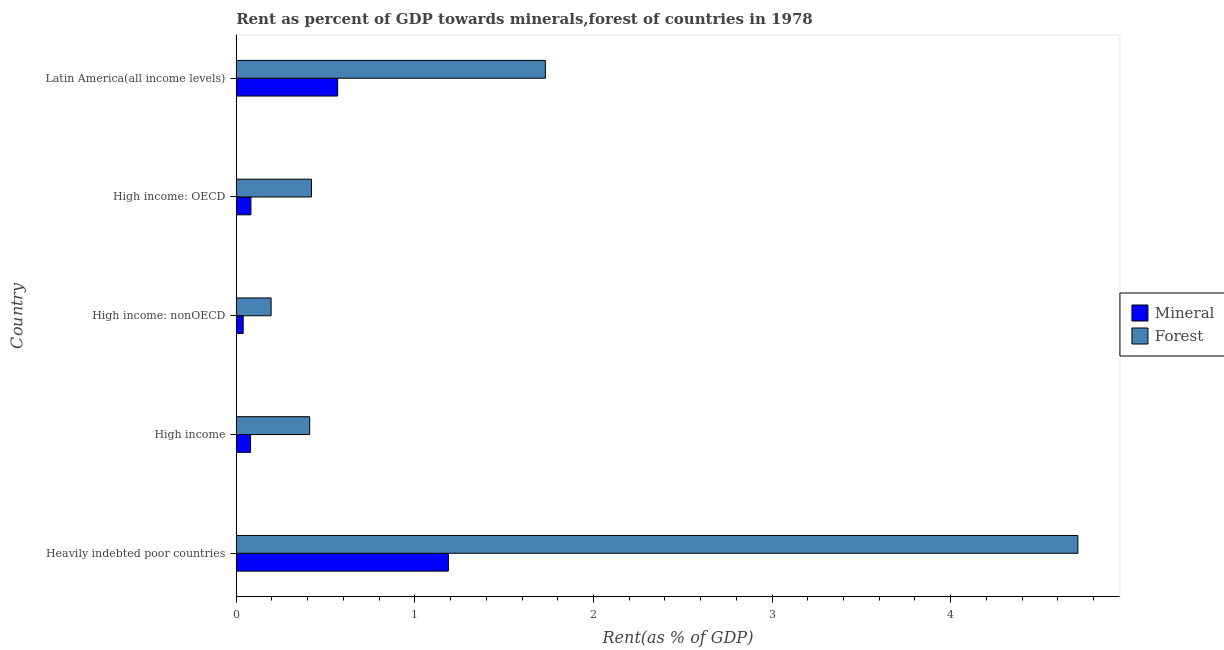How many different coloured bars are there?
Offer a terse response. 2. Are the number of bars per tick equal to the number of legend labels?
Offer a terse response. Yes. Are the number of bars on each tick of the Y-axis equal?
Your answer should be compact. Yes. What is the label of the 1st group of bars from the top?
Make the answer very short. Latin America(all income levels). What is the forest rent in High income: nonOECD?
Keep it short and to the point. 0.2. Across all countries, what is the maximum forest rent?
Provide a short and direct response. 4.71. Across all countries, what is the minimum mineral rent?
Your response must be concise. 0.04. In which country was the mineral rent maximum?
Your response must be concise. Heavily indebted poor countries. In which country was the forest rent minimum?
Keep it short and to the point. High income: nonOECD. What is the total forest rent in the graph?
Keep it short and to the point. 7.47. What is the difference between the forest rent in High income: nonOECD and that in Latin America(all income levels)?
Provide a succinct answer. -1.54. What is the difference between the forest rent in High income and the mineral rent in Heavily indebted poor countries?
Give a very brief answer. -0.78. What is the average forest rent per country?
Make the answer very short. 1.49. What is the difference between the forest rent and mineral rent in High income: OECD?
Make the answer very short. 0.34. What is the ratio of the mineral rent in Heavily indebted poor countries to that in High income: OECD?
Keep it short and to the point. 14.48. Is the mineral rent in High income less than that in High income: nonOECD?
Your answer should be very brief. No. Is the difference between the mineral rent in High income: OECD and Latin America(all income levels) greater than the difference between the forest rent in High income: OECD and Latin America(all income levels)?
Offer a terse response. Yes. What is the difference between the highest and the second highest mineral rent?
Provide a succinct answer. 0.62. What is the difference between the highest and the lowest forest rent?
Offer a very short reply. 4.52. What does the 1st bar from the top in High income represents?
Give a very brief answer. Forest. What does the 2nd bar from the bottom in Heavily indebted poor countries represents?
Your response must be concise. Forest. How many bars are there?
Give a very brief answer. 10. What is the difference between two consecutive major ticks on the X-axis?
Make the answer very short. 1. Does the graph contain any zero values?
Make the answer very short. No. Does the graph contain grids?
Offer a very short reply. No. How are the legend labels stacked?
Offer a terse response. Vertical. What is the title of the graph?
Make the answer very short. Rent as percent of GDP towards minerals,forest of countries in 1978. What is the label or title of the X-axis?
Provide a short and direct response. Rent(as % of GDP). What is the Rent(as % of GDP) of Mineral in Heavily indebted poor countries?
Make the answer very short. 1.19. What is the Rent(as % of GDP) in Forest in Heavily indebted poor countries?
Your answer should be compact. 4.71. What is the Rent(as % of GDP) in Mineral in High income?
Provide a succinct answer. 0.08. What is the Rent(as % of GDP) in Forest in High income?
Provide a short and direct response. 0.41. What is the Rent(as % of GDP) of Mineral in High income: nonOECD?
Make the answer very short. 0.04. What is the Rent(as % of GDP) of Forest in High income: nonOECD?
Provide a succinct answer. 0.2. What is the Rent(as % of GDP) in Mineral in High income: OECD?
Your answer should be compact. 0.08. What is the Rent(as % of GDP) of Forest in High income: OECD?
Make the answer very short. 0.42. What is the Rent(as % of GDP) of Mineral in Latin America(all income levels)?
Your answer should be very brief. 0.57. What is the Rent(as % of GDP) of Forest in Latin America(all income levels)?
Provide a succinct answer. 1.73. Across all countries, what is the maximum Rent(as % of GDP) in Mineral?
Give a very brief answer. 1.19. Across all countries, what is the maximum Rent(as % of GDP) in Forest?
Offer a terse response. 4.71. Across all countries, what is the minimum Rent(as % of GDP) of Mineral?
Give a very brief answer. 0.04. Across all countries, what is the minimum Rent(as % of GDP) in Forest?
Keep it short and to the point. 0.2. What is the total Rent(as % of GDP) in Mineral in the graph?
Offer a very short reply. 1.96. What is the total Rent(as % of GDP) in Forest in the graph?
Offer a terse response. 7.47. What is the difference between the Rent(as % of GDP) of Mineral in Heavily indebted poor countries and that in High income?
Your answer should be very brief. 1.11. What is the difference between the Rent(as % of GDP) in Forest in Heavily indebted poor countries and that in High income?
Your answer should be compact. 4.3. What is the difference between the Rent(as % of GDP) in Mineral in Heavily indebted poor countries and that in High income: nonOECD?
Provide a short and direct response. 1.15. What is the difference between the Rent(as % of GDP) of Forest in Heavily indebted poor countries and that in High income: nonOECD?
Offer a terse response. 4.52. What is the difference between the Rent(as % of GDP) in Mineral in Heavily indebted poor countries and that in High income: OECD?
Make the answer very short. 1.11. What is the difference between the Rent(as % of GDP) in Forest in Heavily indebted poor countries and that in High income: OECD?
Provide a succinct answer. 4.29. What is the difference between the Rent(as % of GDP) in Mineral in Heavily indebted poor countries and that in Latin America(all income levels)?
Offer a very short reply. 0.62. What is the difference between the Rent(as % of GDP) in Forest in Heavily indebted poor countries and that in Latin America(all income levels)?
Ensure brevity in your answer.  2.98. What is the difference between the Rent(as % of GDP) of Mineral in High income and that in High income: nonOECD?
Keep it short and to the point. 0.04. What is the difference between the Rent(as % of GDP) of Forest in High income and that in High income: nonOECD?
Ensure brevity in your answer.  0.22. What is the difference between the Rent(as % of GDP) in Mineral in High income and that in High income: OECD?
Offer a terse response. -0. What is the difference between the Rent(as % of GDP) in Forest in High income and that in High income: OECD?
Offer a very short reply. -0.01. What is the difference between the Rent(as % of GDP) in Mineral in High income and that in Latin America(all income levels)?
Make the answer very short. -0.49. What is the difference between the Rent(as % of GDP) in Forest in High income and that in Latin America(all income levels)?
Provide a short and direct response. -1.32. What is the difference between the Rent(as % of GDP) in Mineral in High income: nonOECD and that in High income: OECD?
Keep it short and to the point. -0.04. What is the difference between the Rent(as % of GDP) in Forest in High income: nonOECD and that in High income: OECD?
Your answer should be compact. -0.23. What is the difference between the Rent(as % of GDP) in Mineral in High income: nonOECD and that in Latin America(all income levels)?
Your response must be concise. -0.53. What is the difference between the Rent(as % of GDP) in Forest in High income: nonOECD and that in Latin America(all income levels)?
Provide a short and direct response. -1.54. What is the difference between the Rent(as % of GDP) in Mineral in High income: OECD and that in Latin America(all income levels)?
Your answer should be very brief. -0.49. What is the difference between the Rent(as % of GDP) in Forest in High income: OECD and that in Latin America(all income levels)?
Your answer should be compact. -1.31. What is the difference between the Rent(as % of GDP) of Mineral in Heavily indebted poor countries and the Rent(as % of GDP) of Forest in High income?
Give a very brief answer. 0.78. What is the difference between the Rent(as % of GDP) of Mineral in Heavily indebted poor countries and the Rent(as % of GDP) of Forest in High income: OECD?
Give a very brief answer. 0.77. What is the difference between the Rent(as % of GDP) of Mineral in Heavily indebted poor countries and the Rent(as % of GDP) of Forest in Latin America(all income levels)?
Ensure brevity in your answer.  -0.54. What is the difference between the Rent(as % of GDP) in Mineral in High income and the Rent(as % of GDP) in Forest in High income: nonOECD?
Ensure brevity in your answer.  -0.12. What is the difference between the Rent(as % of GDP) of Mineral in High income and the Rent(as % of GDP) of Forest in High income: OECD?
Make the answer very short. -0.34. What is the difference between the Rent(as % of GDP) of Mineral in High income and the Rent(as % of GDP) of Forest in Latin America(all income levels)?
Offer a terse response. -1.65. What is the difference between the Rent(as % of GDP) of Mineral in High income: nonOECD and the Rent(as % of GDP) of Forest in High income: OECD?
Ensure brevity in your answer.  -0.38. What is the difference between the Rent(as % of GDP) of Mineral in High income: nonOECD and the Rent(as % of GDP) of Forest in Latin America(all income levels)?
Your answer should be very brief. -1.69. What is the difference between the Rent(as % of GDP) of Mineral in High income: OECD and the Rent(as % of GDP) of Forest in Latin America(all income levels)?
Provide a succinct answer. -1.65. What is the average Rent(as % of GDP) in Mineral per country?
Provide a short and direct response. 0.39. What is the average Rent(as % of GDP) in Forest per country?
Provide a succinct answer. 1.49. What is the difference between the Rent(as % of GDP) of Mineral and Rent(as % of GDP) of Forest in Heavily indebted poor countries?
Your response must be concise. -3.52. What is the difference between the Rent(as % of GDP) of Mineral and Rent(as % of GDP) of Forest in High income?
Give a very brief answer. -0.33. What is the difference between the Rent(as % of GDP) in Mineral and Rent(as % of GDP) in Forest in High income: nonOECD?
Keep it short and to the point. -0.16. What is the difference between the Rent(as % of GDP) of Mineral and Rent(as % of GDP) of Forest in High income: OECD?
Your response must be concise. -0.34. What is the difference between the Rent(as % of GDP) in Mineral and Rent(as % of GDP) in Forest in Latin America(all income levels)?
Offer a terse response. -1.16. What is the ratio of the Rent(as % of GDP) of Mineral in Heavily indebted poor countries to that in High income?
Give a very brief answer. 14.84. What is the ratio of the Rent(as % of GDP) of Forest in Heavily indebted poor countries to that in High income?
Give a very brief answer. 11.46. What is the ratio of the Rent(as % of GDP) in Mineral in Heavily indebted poor countries to that in High income: nonOECD?
Your answer should be compact. 30.58. What is the ratio of the Rent(as % of GDP) in Forest in Heavily indebted poor countries to that in High income: nonOECD?
Your answer should be compact. 24.16. What is the ratio of the Rent(as % of GDP) in Mineral in Heavily indebted poor countries to that in High income: OECD?
Provide a succinct answer. 14.48. What is the ratio of the Rent(as % of GDP) of Forest in Heavily indebted poor countries to that in High income: OECD?
Your response must be concise. 11.19. What is the ratio of the Rent(as % of GDP) in Mineral in Heavily indebted poor countries to that in Latin America(all income levels)?
Offer a very short reply. 2.09. What is the ratio of the Rent(as % of GDP) in Forest in Heavily indebted poor countries to that in Latin America(all income levels)?
Keep it short and to the point. 2.72. What is the ratio of the Rent(as % of GDP) in Mineral in High income to that in High income: nonOECD?
Your response must be concise. 2.06. What is the ratio of the Rent(as % of GDP) in Forest in High income to that in High income: nonOECD?
Make the answer very short. 2.11. What is the ratio of the Rent(as % of GDP) of Mineral in High income to that in High income: OECD?
Make the answer very short. 0.98. What is the ratio of the Rent(as % of GDP) of Forest in High income to that in High income: OECD?
Your answer should be very brief. 0.98. What is the ratio of the Rent(as % of GDP) in Mineral in High income to that in Latin America(all income levels)?
Offer a terse response. 0.14. What is the ratio of the Rent(as % of GDP) of Forest in High income to that in Latin America(all income levels)?
Offer a terse response. 0.24. What is the ratio of the Rent(as % of GDP) in Mineral in High income: nonOECD to that in High income: OECD?
Make the answer very short. 0.47. What is the ratio of the Rent(as % of GDP) in Forest in High income: nonOECD to that in High income: OECD?
Your answer should be very brief. 0.46. What is the ratio of the Rent(as % of GDP) of Mineral in High income: nonOECD to that in Latin America(all income levels)?
Your response must be concise. 0.07. What is the ratio of the Rent(as % of GDP) of Forest in High income: nonOECD to that in Latin America(all income levels)?
Offer a very short reply. 0.11. What is the ratio of the Rent(as % of GDP) in Mineral in High income: OECD to that in Latin America(all income levels)?
Make the answer very short. 0.14. What is the ratio of the Rent(as % of GDP) in Forest in High income: OECD to that in Latin America(all income levels)?
Make the answer very short. 0.24. What is the difference between the highest and the second highest Rent(as % of GDP) of Mineral?
Give a very brief answer. 0.62. What is the difference between the highest and the second highest Rent(as % of GDP) of Forest?
Your answer should be very brief. 2.98. What is the difference between the highest and the lowest Rent(as % of GDP) in Mineral?
Your answer should be very brief. 1.15. What is the difference between the highest and the lowest Rent(as % of GDP) of Forest?
Your response must be concise. 4.52. 